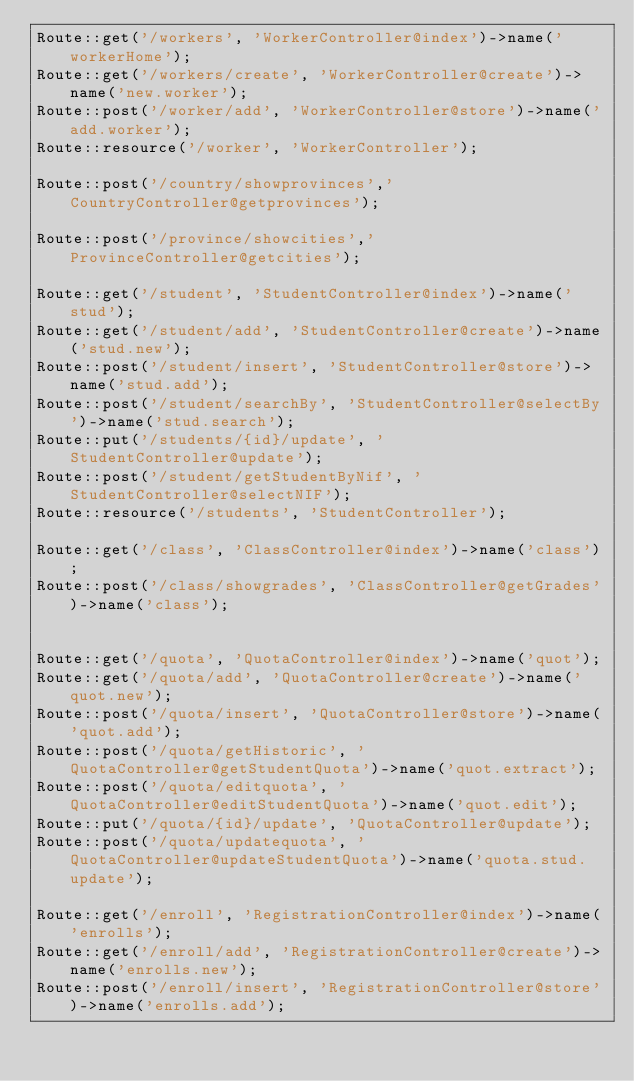Convert code to text. <code><loc_0><loc_0><loc_500><loc_500><_PHP_>Route::get('/workers', 'WorkerController@index')->name('workerHome');
Route::get('/workers/create', 'WorkerController@create')->name('new.worker');
Route::post('/worker/add', 'WorkerController@store')->name('add.worker');
Route::resource('/worker', 'WorkerController');

Route::post('/country/showprovinces','CountryController@getprovinces');

Route::post('/province/showcities','ProvinceController@getcities');

Route::get('/student', 'StudentController@index')->name('stud');
Route::get('/student/add', 'StudentController@create')->name('stud.new');
Route::post('/student/insert', 'StudentController@store')->name('stud.add');
Route::post('/student/searchBy', 'StudentController@selectBy')->name('stud.search');
Route::put('/students/{id}/update', 'StudentController@update');
Route::post('/student/getStudentByNif', 'StudentController@selectNIF');
Route::resource('/students', 'StudentController');

Route::get('/class', 'ClassController@index')->name('class');
Route::post('/class/showgrades', 'ClassController@getGrades')->name('class');


Route::get('/quota', 'QuotaController@index')->name('quot');
Route::get('/quota/add', 'QuotaController@create')->name('quot.new');
Route::post('/quota/insert', 'QuotaController@store')->name('quot.add');
Route::post('/quota/getHistoric', 'QuotaController@getStudentQuota')->name('quot.extract');
Route::post('/quota/editquota', 'QuotaController@editStudentQuota')->name('quot.edit');
Route::put('/quota/{id}/update', 'QuotaController@update');
Route::post('/quota/updatequota', 'QuotaController@updateStudentQuota')->name('quota.stud.update');

Route::get('/enroll', 'RegistrationController@index')->name('enrolls');
Route::get('/enroll/add', 'RegistrationController@create')->name('enrolls.new');
Route::post('/enroll/insert', 'RegistrationController@store')->name('enrolls.add');

</code> 